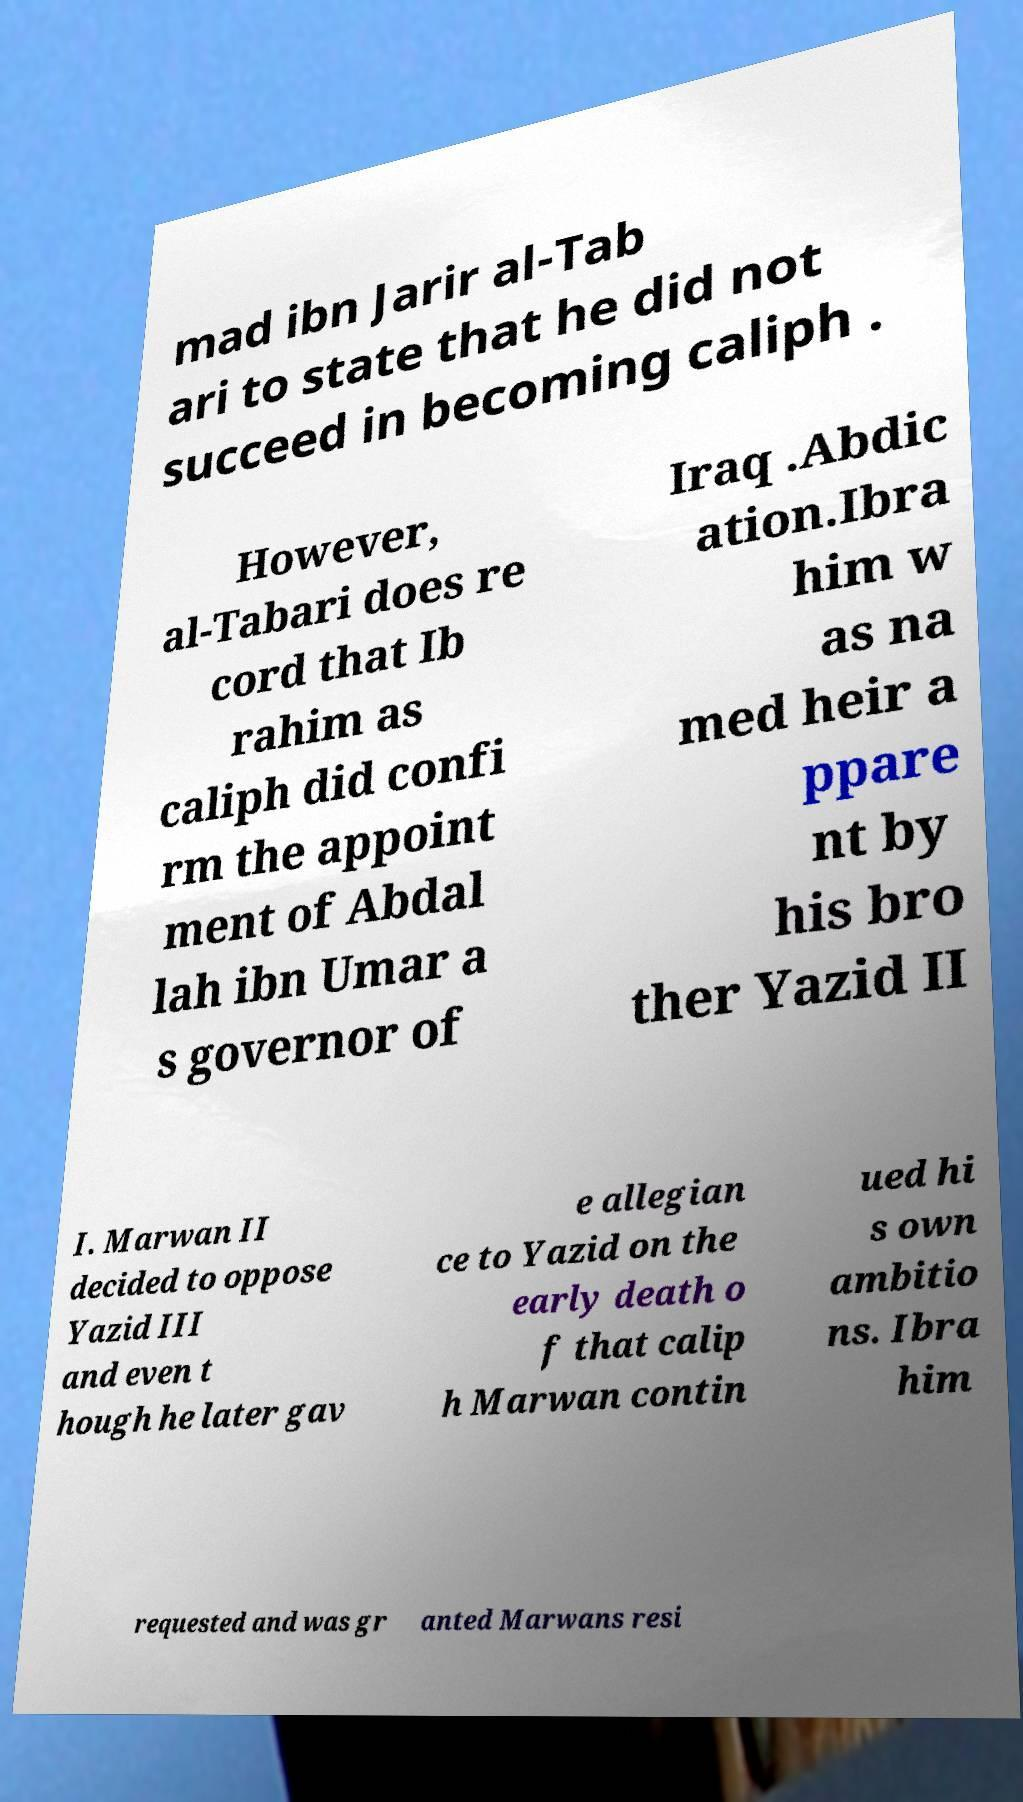Please identify and transcribe the text found in this image. mad ibn Jarir al-Tab ari to state that he did not succeed in becoming caliph . However, al-Tabari does re cord that Ib rahim as caliph did confi rm the appoint ment of Abdal lah ibn Umar a s governor of Iraq .Abdic ation.Ibra him w as na med heir a ppare nt by his bro ther Yazid II I. Marwan II decided to oppose Yazid III and even t hough he later gav e allegian ce to Yazid on the early death o f that calip h Marwan contin ued hi s own ambitio ns. Ibra him requested and was gr anted Marwans resi 